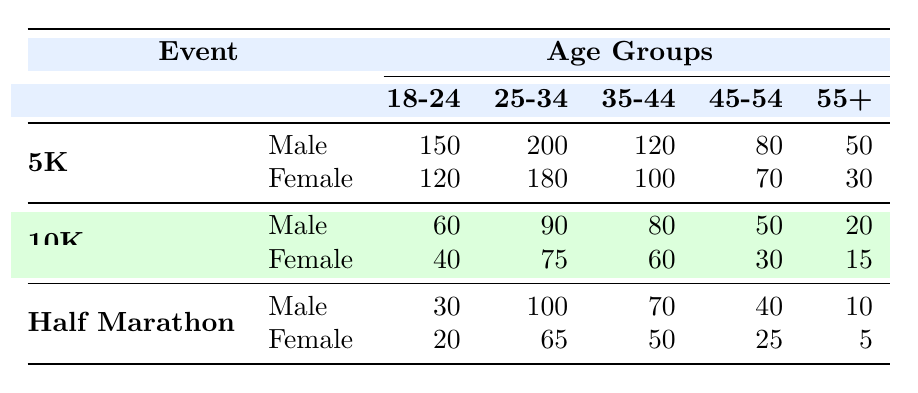What is the total number of male participants in the 5K event? To find the total number of male participants in the 5K, we add the numbers across all age groups: 150 (18-24) + 200 (25-34) + 120 (35-44) + 80 (45-54) + 50 (55+) = 600.
Answer: 600 How many female participants aged 35-44 participated in the 10K event? Referring to the 10K row under the Female category, the number for the 35-44 age group is listed as 60.
Answer: 60 Is there a larger participation of males in the 25-34 age group for the Half Marathon than in the 10K event? In the Half Marathon, the number of male participants in the 25-34 age group is 100, while in the 10K, it is 90. Since 100 is greater than 90, the statement is true.
Answer: Yes What is the average number of female participants across all events in the 18-24 age group? For Females in the 18-24 age group across all events: 120 (5K) + 40 (10K) + 20 (Half Marathon) = 180. There are 3 events, so the average is 180/3 = 60.
Answer: 60 How many more male participants are there in the 5K event compared to the Half Marathon event for the age group 45-54? For 45-54 age group: in the 5K, there are 80 male participants, and in the Half Marathon, there are 40. The difference is 80 - 40 = 40 more participants in the 5K.
Answer: 40 Which event had the highest male participation in the 18-24 age group? By comparing the numbers across events for males aged 18-24: 150 (5K), 60 (10K), and 30 (Half Marathon). The highest is clearly 150 from the 5K event.
Answer: 5K Are there more female participants aged 45-54 in the Half Marathon or the 10K event? In the 10K event, there are 30 female participants aged 45-54, while in the Half Marathon, there are 25. Since 30 is greater than 25, there are more in the 10K.
Answer: 10K What is the total number of participants (male and female) aged 55 and older in the 10K event? For the 10K event, males aged 55+ are 20, and females aged 55+ are 15. Thus, total = 20 + 15 = 35 participants in that age group.
Answer: 35 